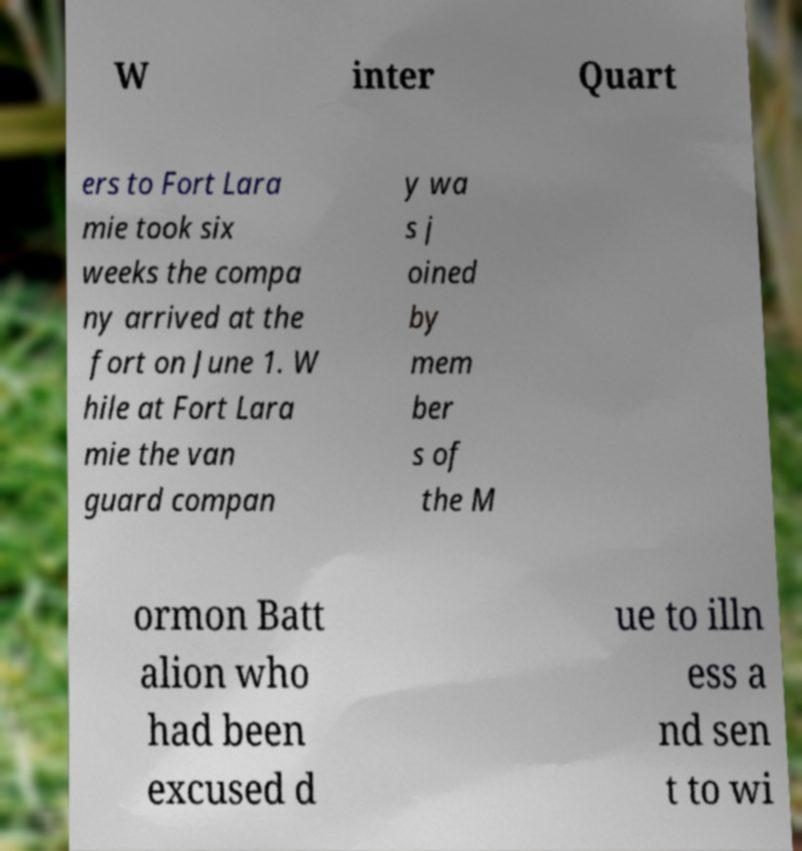Could you assist in decoding the text presented in this image and type it out clearly? W inter Quart ers to Fort Lara mie took six weeks the compa ny arrived at the fort on June 1. W hile at Fort Lara mie the van guard compan y wa s j oined by mem ber s of the M ormon Batt alion who had been excused d ue to illn ess a nd sen t to wi 